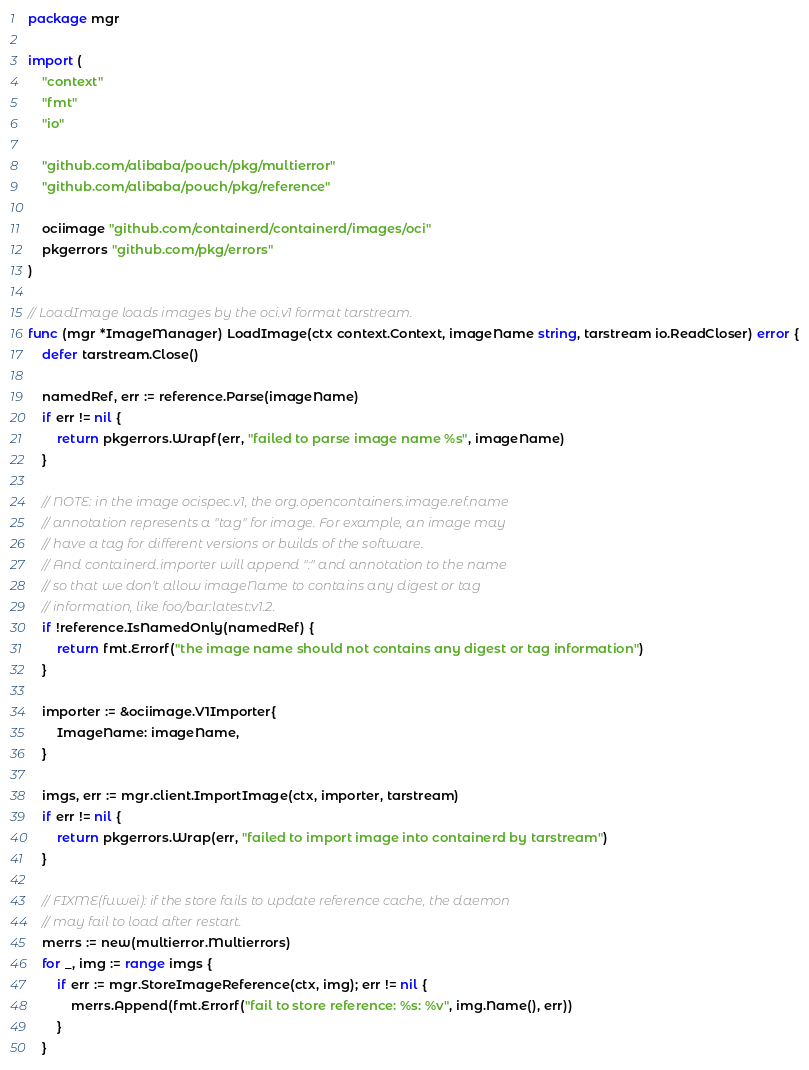Convert code to text. <code><loc_0><loc_0><loc_500><loc_500><_Go_>package mgr

import (
	"context"
	"fmt"
	"io"

	"github.com/alibaba/pouch/pkg/multierror"
	"github.com/alibaba/pouch/pkg/reference"

	ociimage "github.com/containerd/containerd/images/oci"
	pkgerrors "github.com/pkg/errors"
)

// LoadImage loads images by the oci.v1 format tarstream.
func (mgr *ImageManager) LoadImage(ctx context.Context, imageName string, tarstream io.ReadCloser) error {
	defer tarstream.Close()

	namedRef, err := reference.Parse(imageName)
	if err != nil {
		return pkgerrors.Wrapf(err, "failed to parse image name %s", imageName)
	}

	// NOTE: in the image ocispec.v1, the org.opencontainers.image.ref.name
	// annotation represents a "tag" for image. For example, an image may
	// have a tag for different versions or builds of the software.
	// And containerd.importer will append ":" and annotation to the name
	// so that we don't allow imageName to contains any digest or tag
	// information, like foo/bar:latest:v1.2.
	if !reference.IsNamedOnly(namedRef) {
		return fmt.Errorf("the image name should not contains any digest or tag information")
	}

	importer := &ociimage.V1Importer{
		ImageName: imageName,
	}

	imgs, err := mgr.client.ImportImage(ctx, importer, tarstream)
	if err != nil {
		return pkgerrors.Wrap(err, "failed to import image into containerd by tarstream")
	}

	// FIXME(fuwei): if the store fails to update reference cache, the daemon
	// may fail to load after restart.
	merrs := new(multierror.Multierrors)
	for _, img := range imgs {
		if err := mgr.StoreImageReference(ctx, img); err != nil {
			merrs.Append(fmt.Errorf("fail to store reference: %s: %v", img.Name(), err))
		}
	}
</code> 